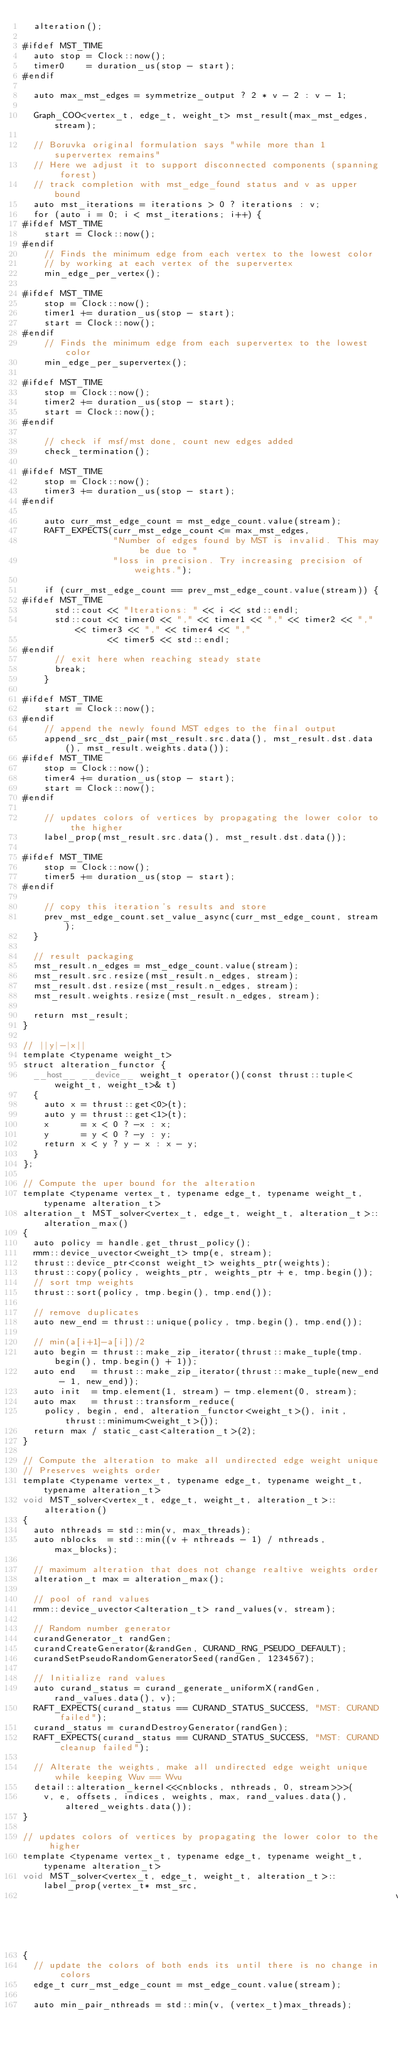<code> <loc_0><loc_0><loc_500><loc_500><_Cuda_>  alteration();

#ifdef MST_TIME
  auto stop = Clock::now();
  timer0    = duration_us(stop - start);
#endif

  auto max_mst_edges = symmetrize_output ? 2 * v - 2 : v - 1;

  Graph_COO<vertex_t, edge_t, weight_t> mst_result(max_mst_edges, stream);

  // Boruvka original formulation says "while more than 1 supervertex remains"
  // Here we adjust it to support disconnected components (spanning forest)
  // track completion with mst_edge_found status and v as upper bound
  auto mst_iterations = iterations > 0 ? iterations : v;
  for (auto i = 0; i < mst_iterations; i++) {
#ifdef MST_TIME
    start = Clock::now();
#endif
    // Finds the minimum edge from each vertex to the lowest color
    // by working at each vertex of the supervertex
    min_edge_per_vertex();

#ifdef MST_TIME
    stop = Clock::now();
    timer1 += duration_us(stop - start);
    start = Clock::now();
#endif
    // Finds the minimum edge from each supervertex to the lowest color
    min_edge_per_supervertex();

#ifdef MST_TIME
    stop = Clock::now();
    timer2 += duration_us(stop - start);
    start = Clock::now();
#endif

    // check if msf/mst done, count new edges added
    check_termination();

#ifdef MST_TIME
    stop = Clock::now();
    timer3 += duration_us(stop - start);
#endif

    auto curr_mst_edge_count = mst_edge_count.value(stream);
    RAFT_EXPECTS(curr_mst_edge_count <= max_mst_edges,
                 "Number of edges found by MST is invalid. This may be due to "
                 "loss in precision. Try increasing precision of weights.");

    if (curr_mst_edge_count == prev_mst_edge_count.value(stream)) {
#ifdef MST_TIME
      std::cout << "Iterations: " << i << std::endl;
      std::cout << timer0 << "," << timer1 << "," << timer2 << "," << timer3 << "," << timer4 << ","
                << timer5 << std::endl;
#endif
      // exit here when reaching steady state
      break;
    }

#ifdef MST_TIME
    start = Clock::now();
#endif
    // append the newly found MST edges to the final output
    append_src_dst_pair(mst_result.src.data(), mst_result.dst.data(), mst_result.weights.data());
#ifdef MST_TIME
    stop = Clock::now();
    timer4 += duration_us(stop - start);
    start = Clock::now();
#endif

    // updates colors of vertices by propagating the lower color to the higher
    label_prop(mst_result.src.data(), mst_result.dst.data());

#ifdef MST_TIME
    stop = Clock::now();
    timer5 += duration_us(stop - start);
#endif

    // copy this iteration's results and store
    prev_mst_edge_count.set_value_async(curr_mst_edge_count, stream);
  }

  // result packaging
  mst_result.n_edges = mst_edge_count.value(stream);
  mst_result.src.resize(mst_result.n_edges, stream);
  mst_result.dst.resize(mst_result.n_edges, stream);
  mst_result.weights.resize(mst_result.n_edges, stream);

  return mst_result;
}

// ||y|-|x||
template <typename weight_t>
struct alteration_functor {
  __host__ __device__ weight_t operator()(const thrust::tuple<weight_t, weight_t>& t)
  {
    auto x = thrust::get<0>(t);
    auto y = thrust::get<1>(t);
    x      = x < 0 ? -x : x;
    y      = y < 0 ? -y : y;
    return x < y ? y - x : x - y;
  }
};

// Compute the uper bound for the alteration
template <typename vertex_t, typename edge_t, typename weight_t, typename alteration_t>
alteration_t MST_solver<vertex_t, edge_t, weight_t, alteration_t>::alteration_max()
{
  auto policy = handle.get_thrust_policy();
  rmm::device_uvector<weight_t> tmp(e, stream);
  thrust::device_ptr<const weight_t> weights_ptr(weights);
  thrust::copy(policy, weights_ptr, weights_ptr + e, tmp.begin());
  // sort tmp weights
  thrust::sort(policy, tmp.begin(), tmp.end());

  // remove duplicates
  auto new_end = thrust::unique(policy, tmp.begin(), tmp.end());

  // min(a[i+1]-a[i])/2
  auto begin = thrust::make_zip_iterator(thrust::make_tuple(tmp.begin(), tmp.begin() + 1));
  auto end   = thrust::make_zip_iterator(thrust::make_tuple(new_end - 1, new_end));
  auto init  = tmp.element(1, stream) - tmp.element(0, stream);
  auto max   = thrust::transform_reduce(
    policy, begin, end, alteration_functor<weight_t>(), init, thrust::minimum<weight_t>());
  return max / static_cast<alteration_t>(2);
}

// Compute the alteration to make all undirected edge weight unique
// Preserves weights order
template <typename vertex_t, typename edge_t, typename weight_t, typename alteration_t>
void MST_solver<vertex_t, edge_t, weight_t, alteration_t>::alteration()
{
  auto nthreads = std::min(v, max_threads);
  auto nblocks  = std::min((v + nthreads - 1) / nthreads, max_blocks);

  // maximum alteration that does not change realtive weights order
  alteration_t max = alteration_max();

  // pool of rand values
  rmm::device_uvector<alteration_t> rand_values(v, stream);

  // Random number generator
  curandGenerator_t randGen;
  curandCreateGenerator(&randGen, CURAND_RNG_PSEUDO_DEFAULT);
  curandSetPseudoRandomGeneratorSeed(randGen, 1234567);

  // Initialize rand values
  auto curand_status = curand_generate_uniformX(randGen, rand_values.data(), v);
  RAFT_EXPECTS(curand_status == CURAND_STATUS_SUCCESS, "MST: CURAND failed");
  curand_status = curandDestroyGenerator(randGen);
  RAFT_EXPECTS(curand_status == CURAND_STATUS_SUCCESS, "MST: CURAND cleanup failed");

  // Alterate the weights, make all undirected edge weight unique while keeping Wuv == Wvu
  detail::alteration_kernel<<<nblocks, nthreads, 0, stream>>>(
    v, e, offsets, indices, weights, max, rand_values.data(), altered_weights.data());
}

// updates colors of vertices by propagating the lower color to the higher
template <typename vertex_t, typename edge_t, typename weight_t, typename alteration_t>
void MST_solver<vertex_t, edge_t, weight_t, alteration_t>::label_prop(vertex_t* mst_src,
                                                                      vertex_t* mst_dst)
{
  // update the colors of both ends its until there is no change in colors
  edge_t curr_mst_edge_count = mst_edge_count.value(stream);

  auto min_pair_nthreads = std::min(v, (vertex_t)max_threads);</code> 